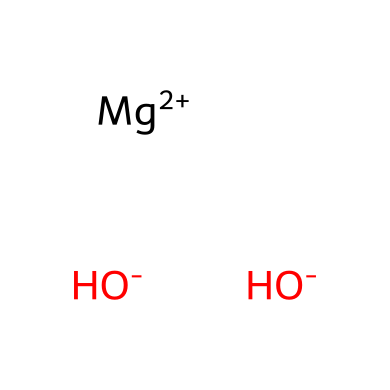how many hydroxide ions are present in magnesium hydroxide? The SMILES representation shows two hydroxide ions, denoted by [OH-], indicating that there are two hydrogen (H) atoms and two oxygen (O) atoms bonded to magnesium.
Answer: two what is the charge on magnesium in this compound? In the SMILES notation, magnesium is represented as [Mg+2], indicating that it has a +2 charge.
Answer: +2 is magnesium hydroxide an acid or a base? Magnesium hydroxide is characterized as a base due to its ability to accept protons and its hydroxide ions.
Answer: base what type of chemical compound is formed by magnesium and hydroxide ions? The combination of magnesium ions and hydroxide ions forms a salt, specifically magnesium hydroxide.
Answer: salt how many total atoms are present in magnesium hydroxide? The chemical structure comprises one magnesium atom, two oxygen atoms, and two hydrogen atoms, making a total of five atoms in the compound.
Answer: five what role do hydroxide ions play in the nature of magnesium hydroxide? Hydroxide ions provide alkalinity to magnesium hydroxide, contributing to its base properties and affecting its behavior in aqueous environments.
Answer: alkalinity why is magnesium hydroxide commonly found in natural hot springs? Magnesium hydroxide precipitates in hot springs due to the reaction of magnesium-rich waters with hydroxide ions present in the environment.
Answer: precipitation 